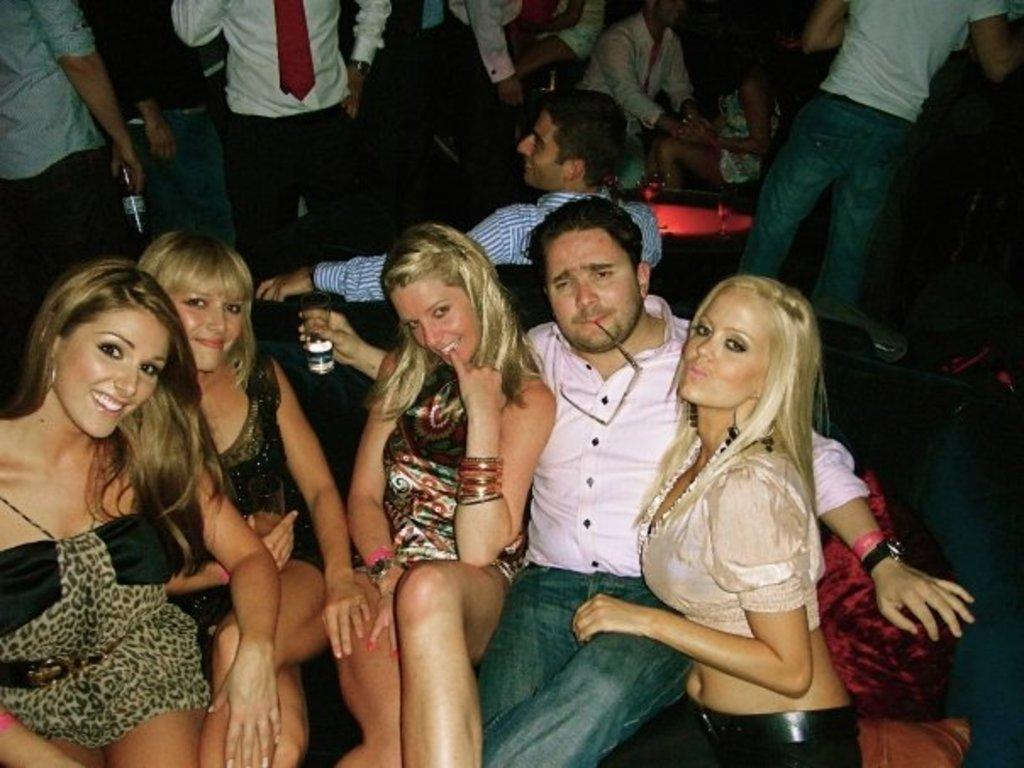How many people are visible in the image? There are many people in the image. Can you describe the grouping of people in the image? There is a man sitting with four girls on a couch. What type of establishment might the image be depicting? The setting appears to be a pub. What type of mice can be seen scurrying around the pub in the image? There are no mice visible in the image. What subject are the people in the image learning about? The image does not depict any learning or educational activity. 